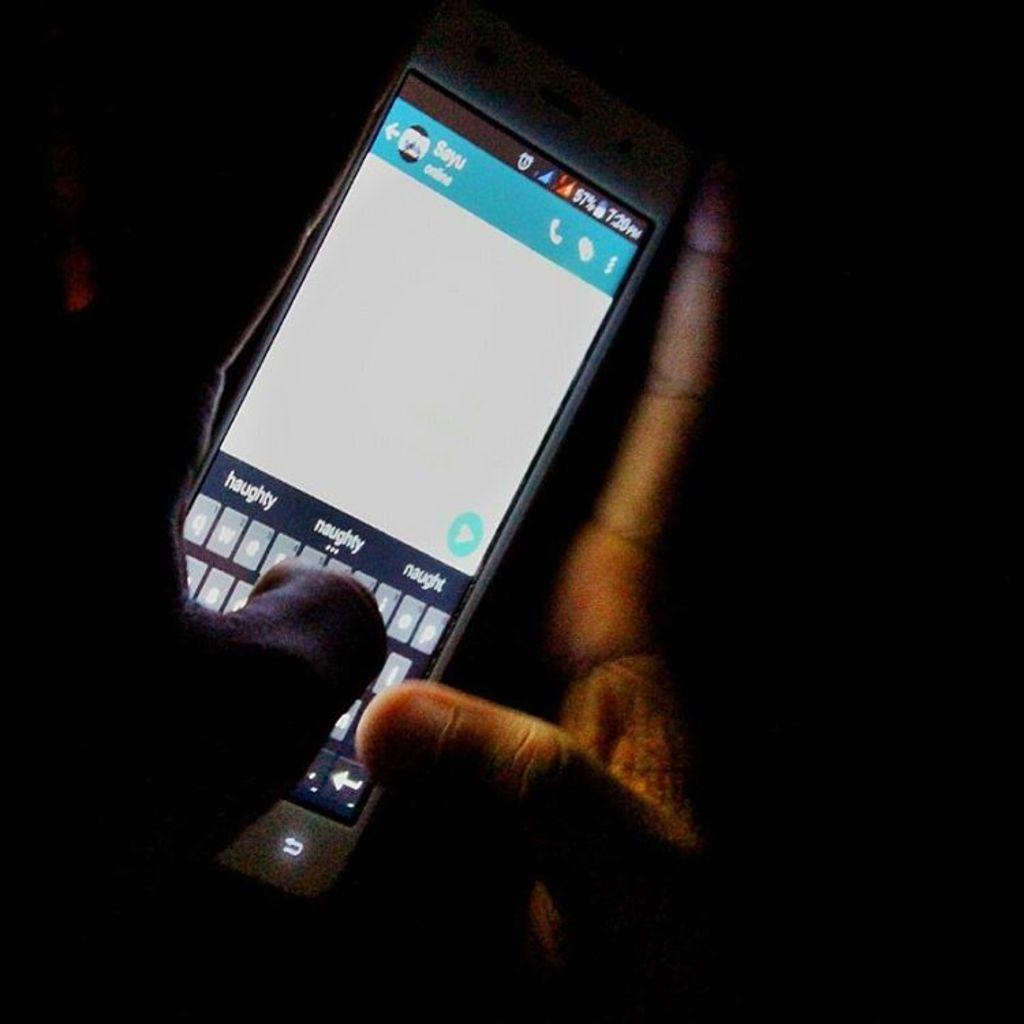<image>
Render a clear and concise summary of the photo. Hands holding a lit cell phone, typing something, with the autosuggest putting up haughty, naughty, and naught. 